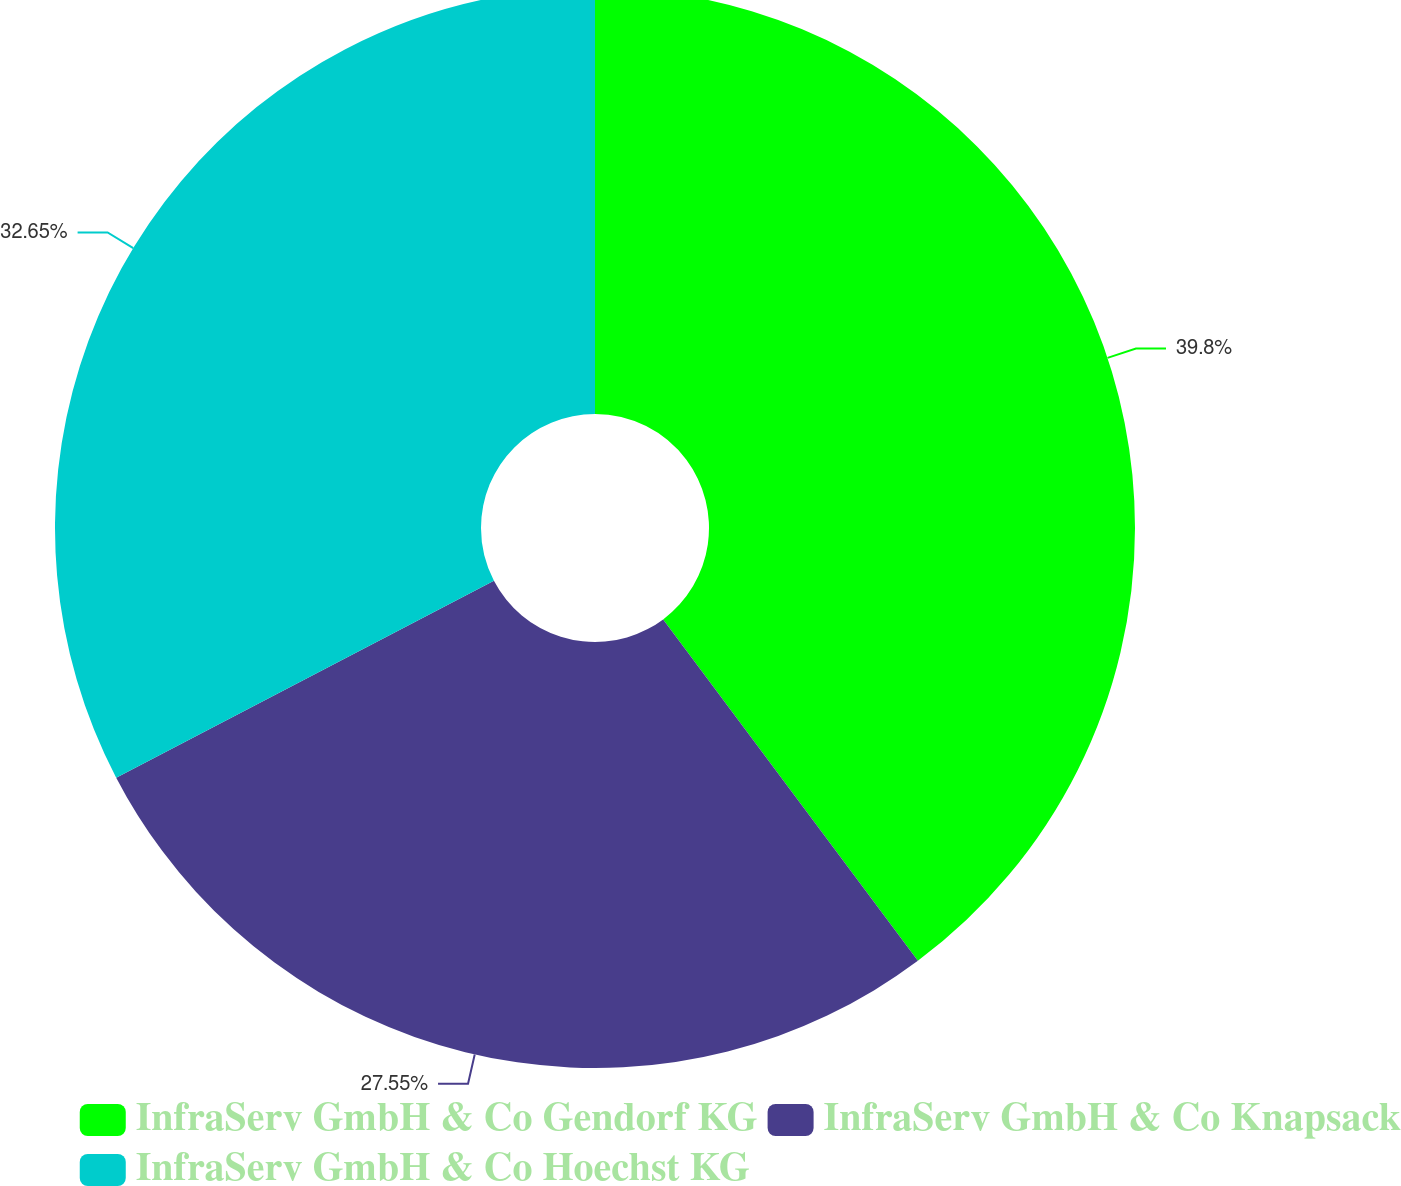Convert chart to OTSL. <chart><loc_0><loc_0><loc_500><loc_500><pie_chart><fcel>InfraServ GmbH & Co Gendorf KG<fcel>InfraServ GmbH & Co Knapsack<fcel>InfraServ GmbH & Co Hoechst KG<nl><fcel>39.8%<fcel>27.55%<fcel>32.65%<nl></chart> 